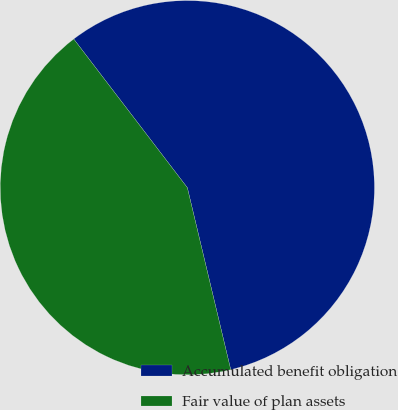Convert chart to OTSL. <chart><loc_0><loc_0><loc_500><loc_500><pie_chart><fcel>Accumulated benefit obligation<fcel>Fair value of plan assets<nl><fcel>56.66%<fcel>43.34%<nl></chart> 